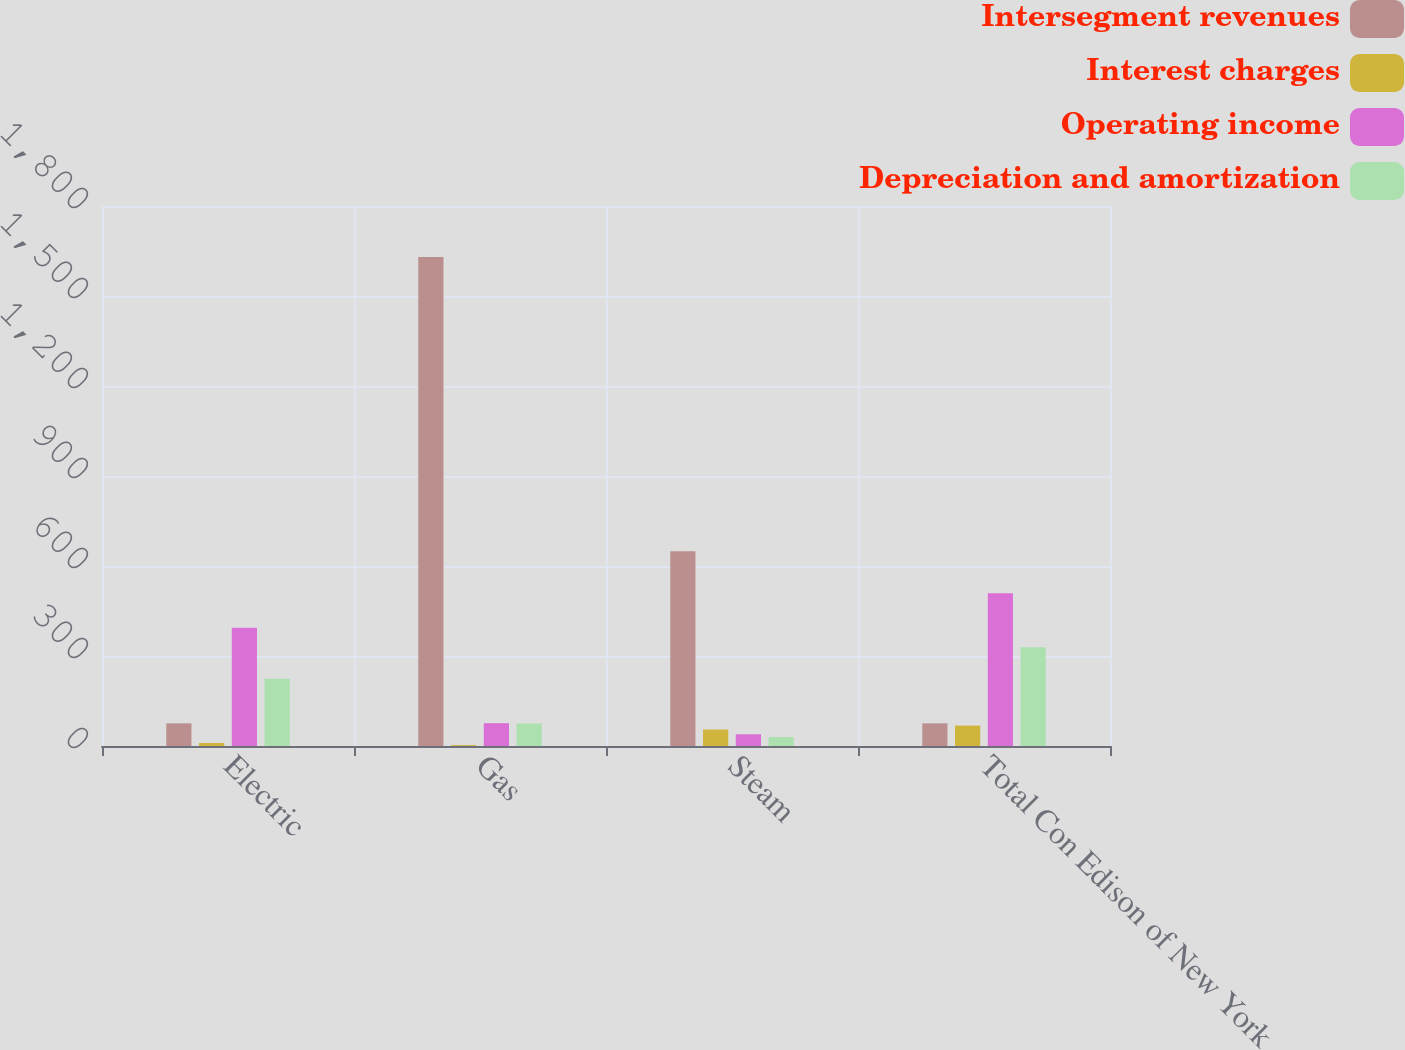Convert chart. <chart><loc_0><loc_0><loc_500><loc_500><stacked_bar_chart><ecel><fcel>Electric<fcel>Gas<fcel>Steam<fcel>Total Con Edison of New York<nl><fcel>Intersegment revenues<fcel>75.5<fcel>1630<fcel>649<fcel>75.5<nl><fcel>Interest charges<fcel>10<fcel>3<fcel>55<fcel>68<nl><fcel>Operating income<fcel>394<fcel>76<fcel>39<fcel>509<nl><fcel>Depreciation and amortization<fcel>224<fcel>75<fcel>30<fcel>329<nl></chart> 